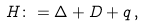<formula> <loc_0><loc_0><loc_500><loc_500>H \colon = \Delta + D + q \, ,</formula> 